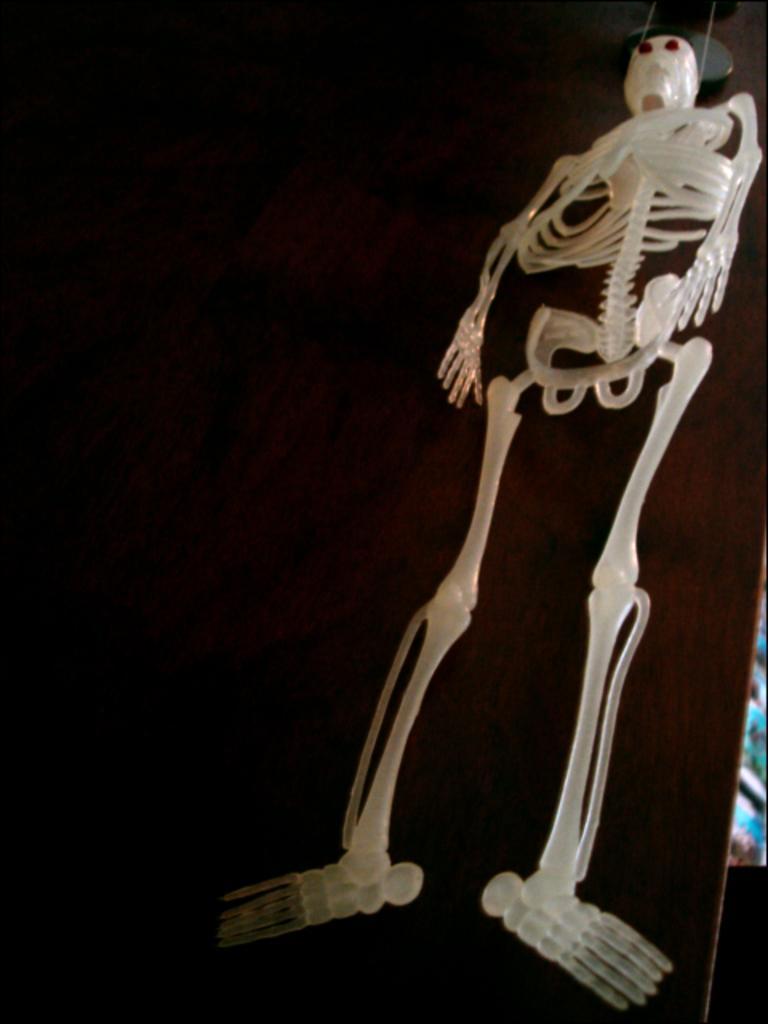Describe this image in one or two sentences. In this image in the center there is one skeleton, and in the background there is one board. 